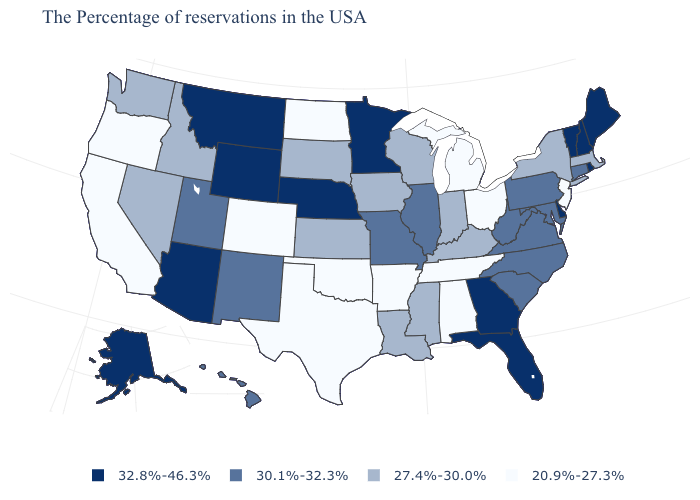What is the value of Hawaii?
Short answer required. 30.1%-32.3%. What is the value of Ohio?
Answer briefly. 20.9%-27.3%. Does Michigan have the lowest value in the MidWest?
Short answer required. Yes. What is the value of Indiana?
Short answer required. 27.4%-30.0%. What is the value of Washington?
Short answer required. 27.4%-30.0%. Does Wisconsin have the lowest value in the MidWest?
Be succinct. No. What is the value of West Virginia?
Concise answer only. 30.1%-32.3%. Name the states that have a value in the range 27.4%-30.0%?
Short answer required. Massachusetts, New York, Kentucky, Indiana, Wisconsin, Mississippi, Louisiana, Iowa, Kansas, South Dakota, Idaho, Nevada, Washington. What is the value of West Virginia?
Concise answer only. 30.1%-32.3%. What is the value of Vermont?
Be succinct. 32.8%-46.3%. Name the states that have a value in the range 20.9%-27.3%?
Concise answer only. New Jersey, Ohio, Michigan, Alabama, Tennessee, Arkansas, Oklahoma, Texas, North Dakota, Colorado, California, Oregon. Name the states that have a value in the range 27.4%-30.0%?
Answer briefly. Massachusetts, New York, Kentucky, Indiana, Wisconsin, Mississippi, Louisiana, Iowa, Kansas, South Dakota, Idaho, Nevada, Washington. What is the lowest value in the USA?
Concise answer only. 20.9%-27.3%. Name the states that have a value in the range 30.1%-32.3%?
Concise answer only. Connecticut, Maryland, Pennsylvania, Virginia, North Carolina, South Carolina, West Virginia, Illinois, Missouri, New Mexico, Utah, Hawaii. Name the states that have a value in the range 27.4%-30.0%?
Answer briefly. Massachusetts, New York, Kentucky, Indiana, Wisconsin, Mississippi, Louisiana, Iowa, Kansas, South Dakota, Idaho, Nevada, Washington. 